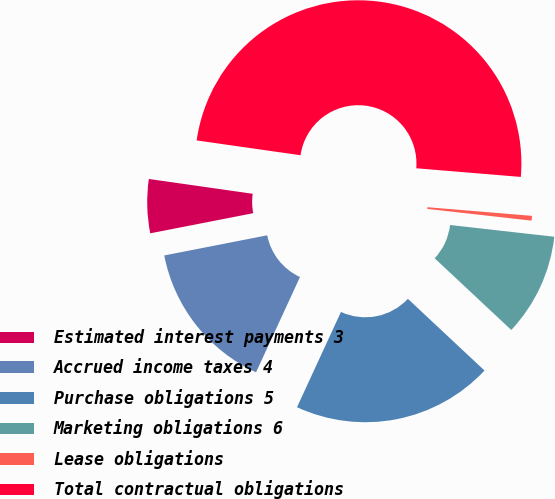Convert chart to OTSL. <chart><loc_0><loc_0><loc_500><loc_500><pie_chart><fcel>Estimated interest payments 3<fcel>Accrued income taxes 4<fcel>Purchase obligations 5<fcel>Marketing obligations 6<fcel>Lease obligations<fcel>Total contractual obligations<nl><fcel>5.33%<fcel>15.05%<fcel>19.91%<fcel>10.19%<fcel>0.47%<fcel>49.07%<nl></chart> 